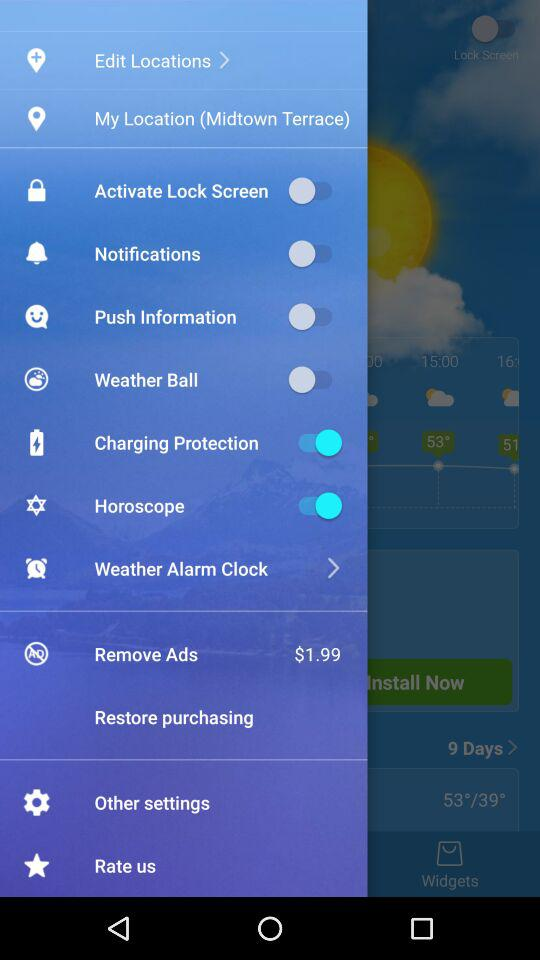What is the price for removing the ads? The price for removing ads is $1.99. 